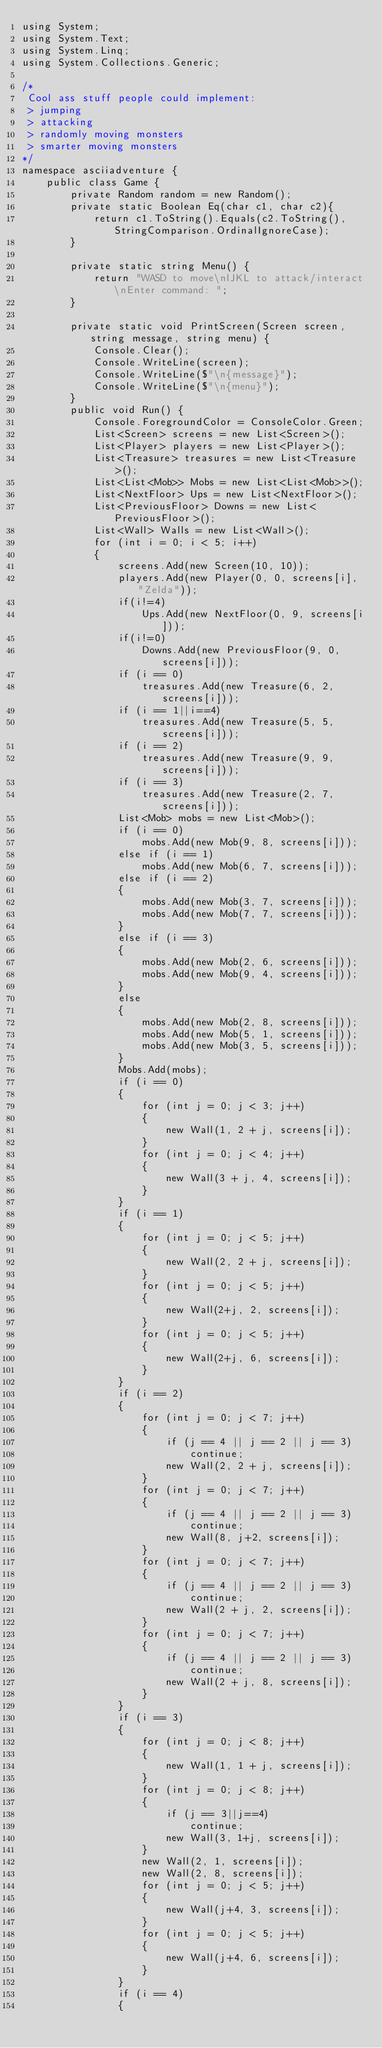<code> <loc_0><loc_0><loc_500><loc_500><_C#_>using System;
using System.Text;
using System.Linq;
using System.Collections.Generic;

/*
 Cool ass stuff people could implement:
 > jumping
 > attacking
 > randomly moving monsters
 > smarter moving monsters
*/
namespace asciiadventure {
    public class Game {
        private Random random = new Random();
        private static Boolean Eq(char c1, char c2){
            return c1.ToString().Equals(c2.ToString(), StringComparison.OrdinalIgnoreCase);
        }

        private static string Menu() {
            return "WASD to move\nIJKL to attack/interact\nEnter command: ";
        }

        private static void PrintScreen(Screen screen, string message, string menu) {
            Console.Clear();
            Console.WriteLine(screen);
            Console.WriteLine($"\n{message}");
            Console.WriteLine($"\n{menu}");
        }
        public void Run() {
            Console.ForegroundColor = ConsoleColor.Green;
            List<Screen> screens = new List<Screen>();
            List<Player> players = new List<Player>();
            List<Treasure> treasures = new List<Treasure>();
            List<List<Mob>> Mobs = new List<List<Mob>>();
            List<NextFloor> Ups = new List<NextFloor>();
            List<PreviousFloor> Downs = new List<PreviousFloor>();
            List<Wall> Walls = new List<Wall>();
            for (int i = 0; i < 5; i++)
            {
                screens.Add(new Screen(10, 10));
                players.Add(new Player(0, 0, screens[i], "Zelda"));
                if(i!=4)
                    Ups.Add(new NextFloor(0, 9, screens[i]));
                if(i!=0)
                    Downs.Add(new PreviousFloor(9, 0, screens[i]));
                if (i == 0)
                    treasures.Add(new Treasure(6, 2, screens[i]));
                if (i == 1||i==4)
                    treasures.Add(new Treasure(5, 5, screens[i]));
                if (i == 2)
                    treasures.Add(new Treasure(9, 9, screens[i]));
                if (i == 3)
                    treasures.Add(new Treasure(2, 7, screens[i]));
                List<Mob> mobs = new List<Mob>();
                if (i == 0) 
                    mobs.Add(new Mob(9, 8, screens[i]));
                else if (i == 1)
                    mobs.Add(new Mob(6, 7, screens[i]));
                else if (i == 2)
                {
                    mobs.Add(new Mob(3, 7, screens[i]));
                    mobs.Add(new Mob(7, 7, screens[i]));
                }
                else if (i == 3)
                {
                    mobs.Add(new Mob(2, 6, screens[i]));
                    mobs.Add(new Mob(9, 4, screens[i]));
                }
                else
                {
                    mobs.Add(new Mob(2, 8, screens[i]));
                    mobs.Add(new Mob(5, 1, screens[i]));
                    mobs.Add(new Mob(3, 5, screens[i]));
                }
                Mobs.Add(mobs);
                if (i == 0)
                {
                    for (int j = 0; j < 3; j++)
                    {
                        new Wall(1, 2 + j, screens[i]);
                    }
                    for (int j = 0; j < 4; j++)
                    {
                        new Wall(3 + j, 4, screens[i]);
                    }
                }
                if (i == 1)
                {
                    for (int j = 0; j < 5; j++)
                    {
                        new Wall(2, 2 + j, screens[i]);
                    }
                    for (int j = 0; j < 5; j++)
                    {
                        new Wall(2+j, 2, screens[i]);
                    }
                    for (int j = 0; j < 5; j++)
                    {
                        new Wall(2+j, 6, screens[i]);
                    }
                }
                if (i == 2)
                {
                    for (int j = 0; j < 7; j++)
                    {
                        if (j == 4 || j == 2 || j == 3)
                            continue;
                        new Wall(2, 2 + j, screens[i]);
                    }
                    for (int j = 0; j < 7; j++)
                    {
                        if (j == 4 || j == 2 || j == 3)
                            continue;
                        new Wall(8, j+2, screens[i]);
                    }
                    for (int j = 0; j < 7; j++)
                    {
                        if (j == 4 || j == 2 || j == 3)
                            continue;
                        new Wall(2 + j, 2, screens[i]);
                    }
                    for (int j = 0; j < 7; j++)
                    {
                        if (j == 4 || j == 2 || j == 3)
                            continue;
                        new Wall(2 + j, 8, screens[i]);
                    }
                }
                if (i == 3)
                {
                    for (int j = 0; j < 8; j++)
                    {
                        new Wall(1, 1 + j, screens[i]);
                    }
                    for (int j = 0; j < 8; j++)
                    {
                        if (j == 3||j==4)
                            continue;
                        new Wall(3, 1+j, screens[i]);
                    }
                    new Wall(2, 1, screens[i]);
                    new Wall(2, 8, screens[i]);
                    for (int j = 0; j < 5; j++)
                    {
                        new Wall(j+4, 3, screens[i]);
                    }
                    for (int j = 0; j < 5; j++)
                    {
                        new Wall(j+4, 6, screens[i]);
                    }
                }
                if (i == 4)
                {</code> 